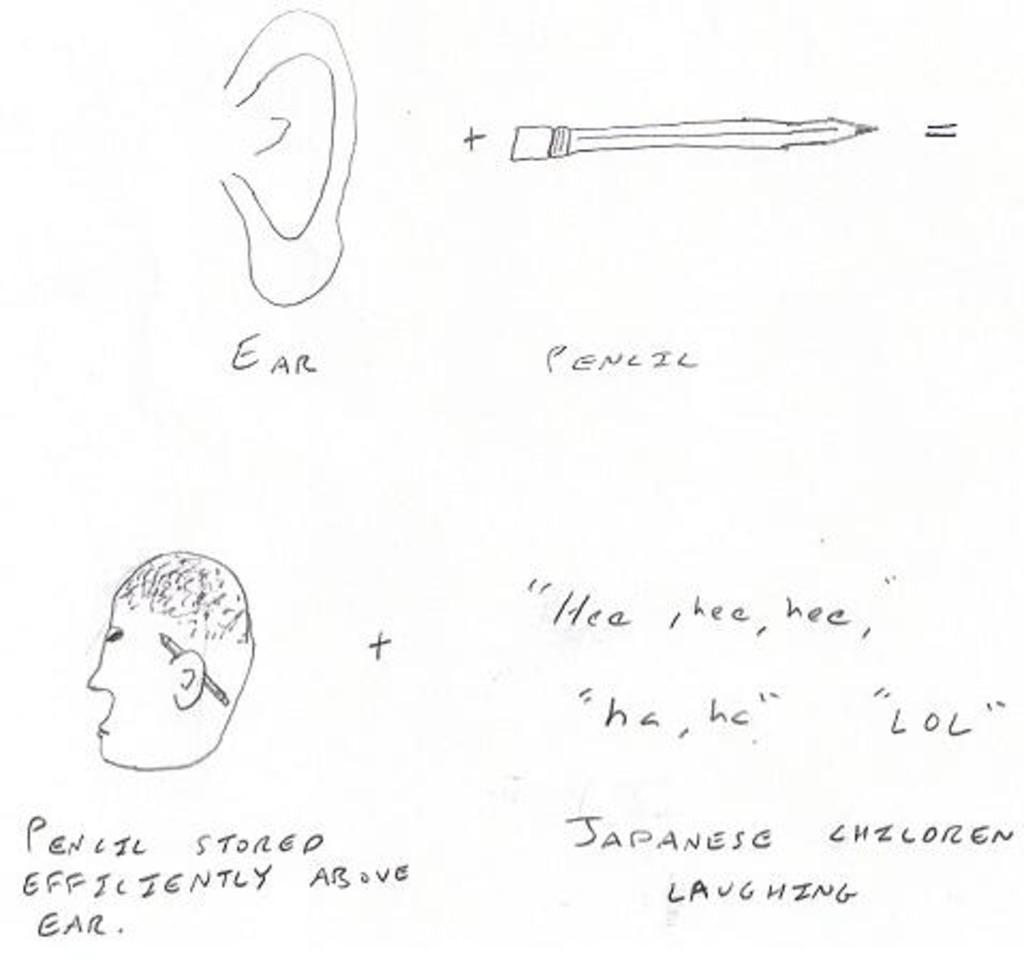<image>
Write a terse but informative summary of the picture. A drawing of an ear, a pencil and laughter 